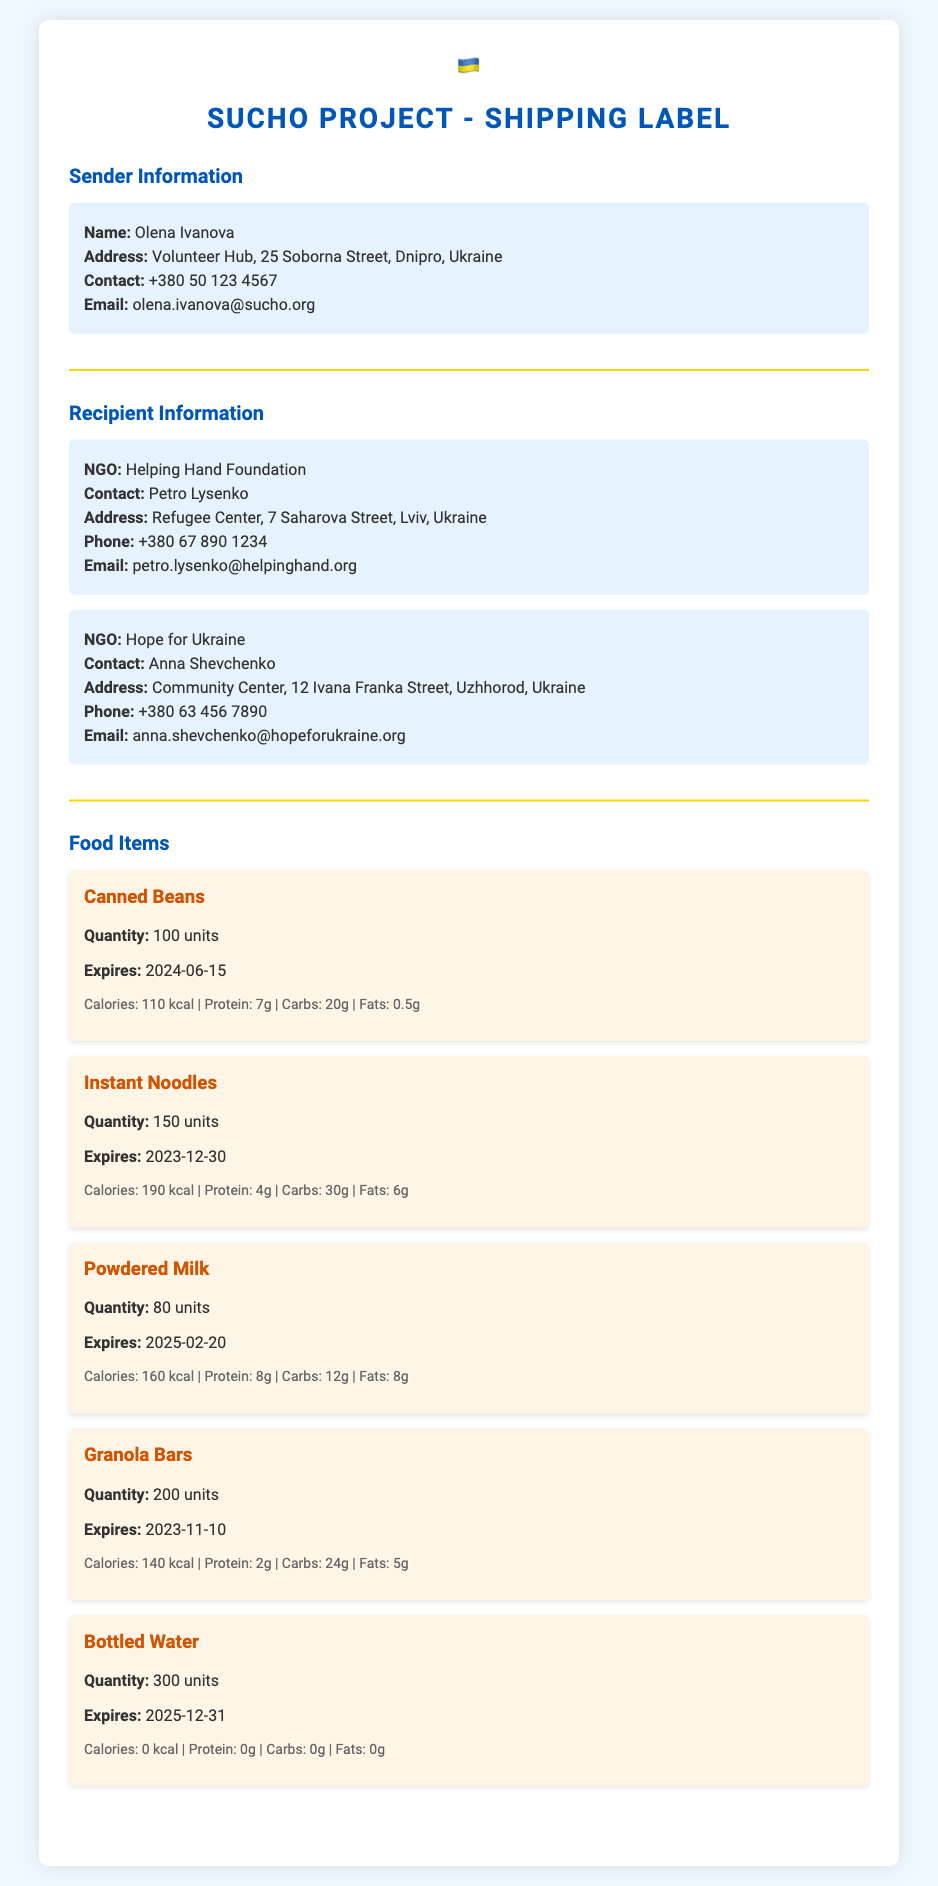what is the name of the sender? The sender's name is listed in the sender information section of the document.
Answer: Olena Ivanova how many units of Instant Noodles are being shipped? The quantity of Instant Noodles is provided in the food items section.
Answer: 150 units which NGO is receiving the food supplies in Lviv? The document specifies the NGO responsible for receiving the shipment in Lviv.
Answer: Helping Hand Foundation when do the Granola Bars expire? The expiration date for Granola Bars is clearly stated in the food items section.
Answer: 2023-11-10 who is the contact person for Hope for Ukraine? The contact for the Hope for Ukraine NGO is mentioned in the recipient information.
Answer: Anna Shevchenko what is the total quantity of Bottled Water being shipped? The document lists the total quantity of Bottled Water in the food items section.
Answer: 300 units which item has the highest calorie content? The document lists the nutritional information for each food item; the item with the highest calories is identified by comparing them.
Answer: Instant Noodles what is the address of the Volunteer Hub? The address of the Volunteer Hub is mentioned in the sender information section.
Answer: 25 Soborna Street, Dnipro, Ukraine how many units of Canned Beans are in the shipment? The quantity of Canned Beans can be found in the food items section of the document.
Answer: 100 units 